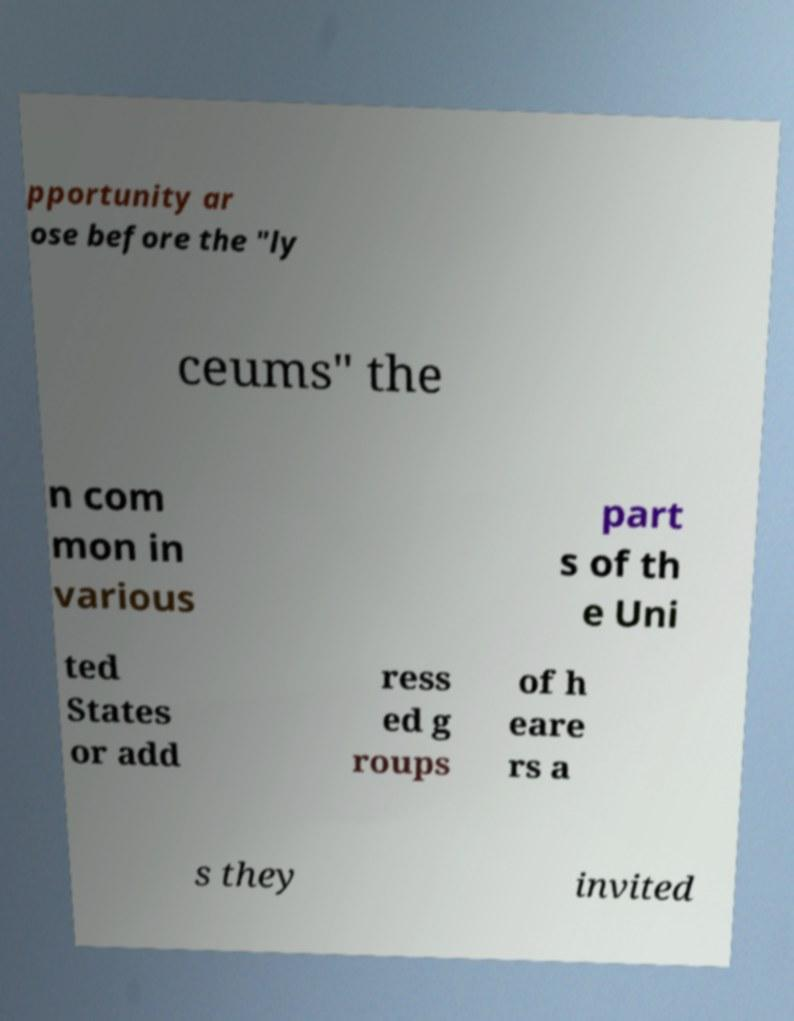Could you extract and type out the text from this image? pportunity ar ose before the "ly ceums" the n com mon in various part s of th e Uni ted States or add ress ed g roups of h eare rs a s they invited 